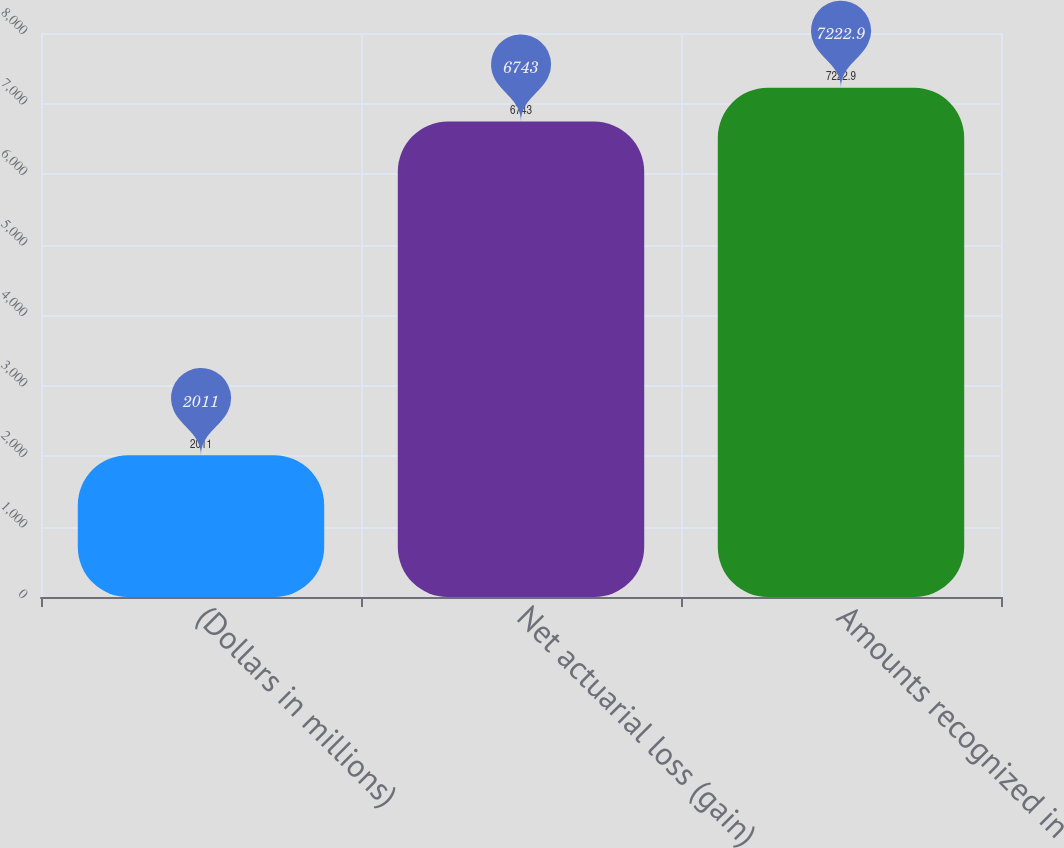<chart> <loc_0><loc_0><loc_500><loc_500><bar_chart><fcel>(Dollars in millions)<fcel>Net actuarial loss (gain)<fcel>Amounts recognized in<nl><fcel>2011<fcel>6743<fcel>7222.9<nl></chart> 